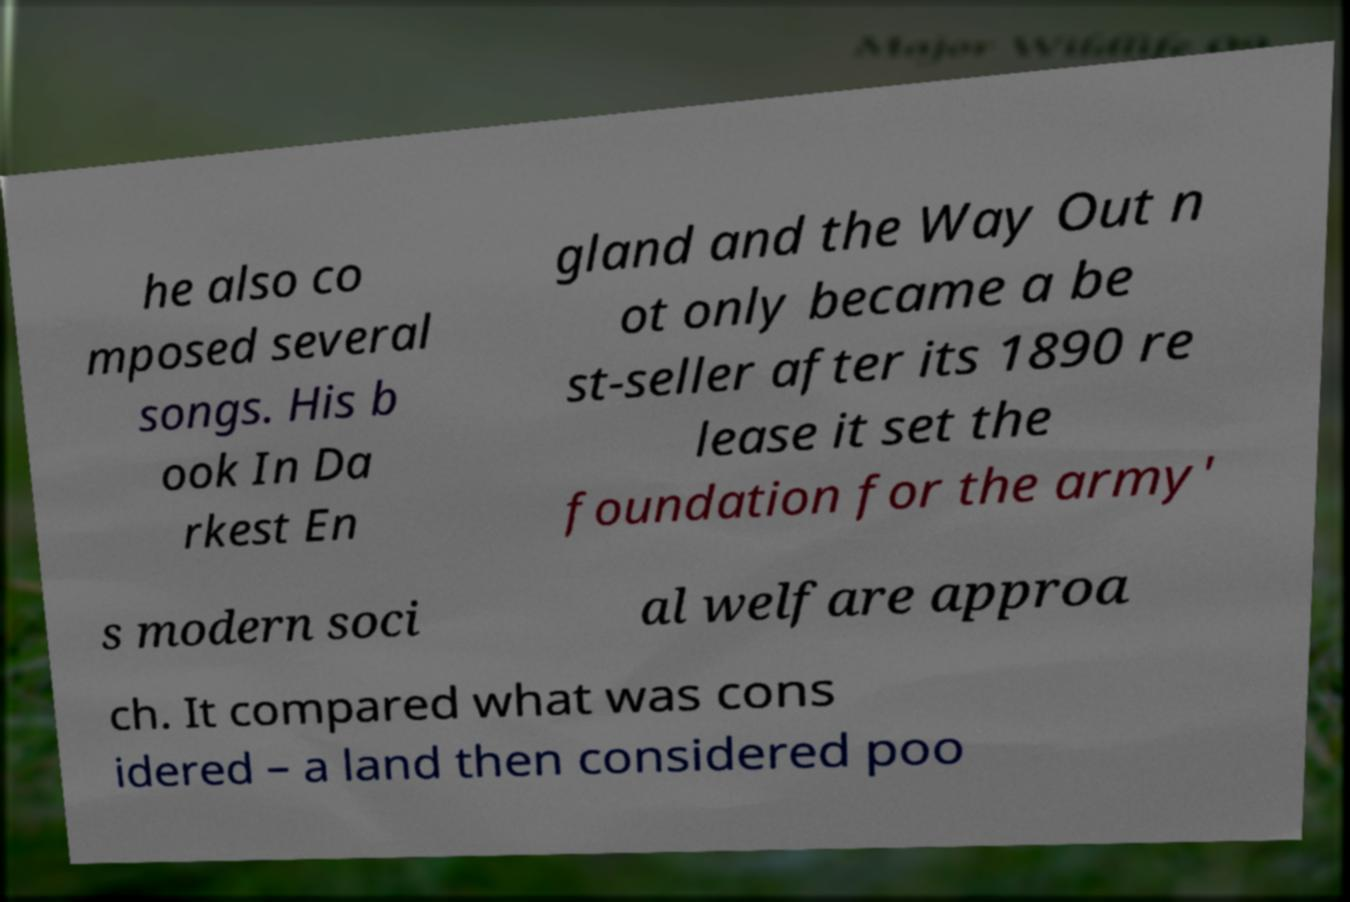Could you extract and type out the text from this image? he also co mposed several songs. His b ook In Da rkest En gland and the Way Out n ot only became a be st-seller after its 1890 re lease it set the foundation for the army' s modern soci al welfare approa ch. It compared what was cons idered – a land then considered poo 